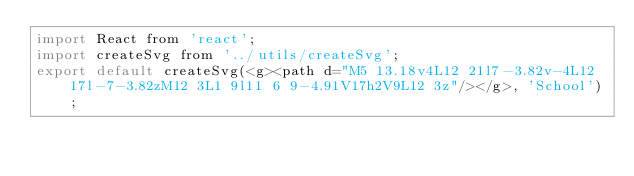<code> <loc_0><loc_0><loc_500><loc_500><_JavaScript_>import React from 'react';
import createSvg from '../utils/createSvg';
export default createSvg(<g><path d="M5 13.18v4L12 21l7-3.82v-4L12 17l-7-3.82zM12 3L1 9l11 6 9-4.91V17h2V9L12 3z"/></g>, 'School');</code> 